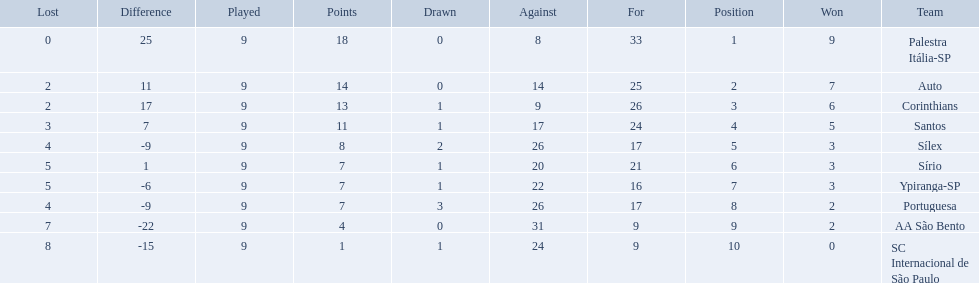How many points were scored by the teams? 18, 14, 13, 11, 8, 7, 7, 7, 4, 1. What team scored 13 points? Corinthians. 